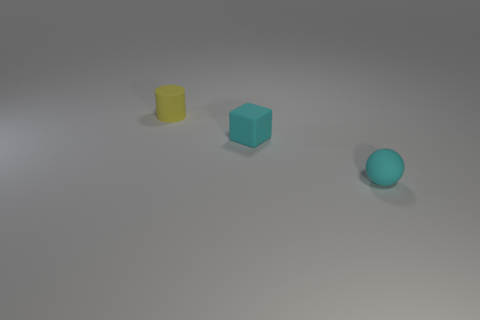Add 1 cyan objects. How many objects exist? 4 Subtract all cylinders. How many objects are left? 2 Add 2 cyan rubber cubes. How many cyan rubber cubes are left? 3 Add 2 small cyan matte things. How many small cyan matte things exist? 4 Subtract 0 blue blocks. How many objects are left? 3 Subtract all tiny cyan blocks. Subtract all large purple cylinders. How many objects are left? 2 